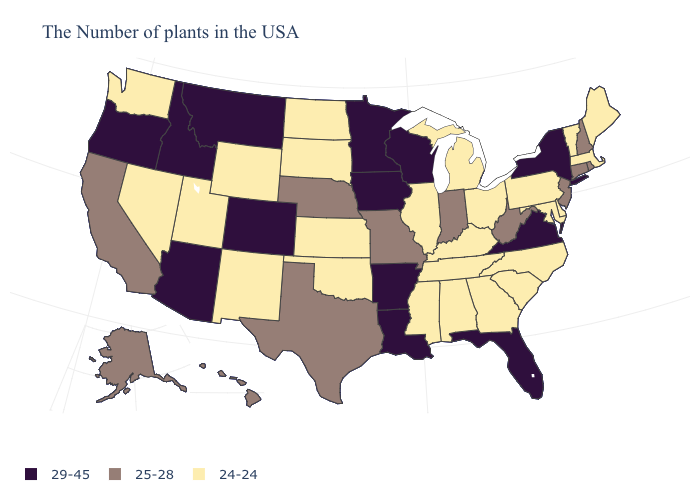What is the highest value in states that border Kansas?
Short answer required. 29-45. Is the legend a continuous bar?
Quick response, please. No. Name the states that have a value in the range 25-28?
Be succinct. Rhode Island, New Hampshire, Connecticut, New Jersey, West Virginia, Indiana, Missouri, Nebraska, Texas, California, Alaska, Hawaii. Which states have the lowest value in the West?
Quick response, please. Wyoming, New Mexico, Utah, Nevada, Washington. What is the lowest value in the USA?
Concise answer only. 24-24. What is the lowest value in the USA?
Concise answer only. 24-24. Name the states that have a value in the range 24-24?
Answer briefly. Maine, Massachusetts, Vermont, Delaware, Maryland, Pennsylvania, North Carolina, South Carolina, Ohio, Georgia, Michigan, Kentucky, Alabama, Tennessee, Illinois, Mississippi, Kansas, Oklahoma, South Dakota, North Dakota, Wyoming, New Mexico, Utah, Nevada, Washington. What is the value of Florida?
Answer briefly. 29-45. What is the value of Hawaii?
Keep it brief. 25-28. Name the states that have a value in the range 29-45?
Quick response, please. New York, Virginia, Florida, Wisconsin, Louisiana, Arkansas, Minnesota, Iowa, Colorado, Montana, Arizona, Idaho, Oregon. Name the states that have a value in the range 29-45?
Short answer required. New York, Virginia, Florida, Wisconsin, Louisiana, Arkansas, Minnesota, Iowa, Colorado, Montana, Arizona, Idaho, Oregon. Which states have the lowest value in the West?
Answer briefly. Wyoming, New Mexico, Utah, Nevada, Washington. What is the value of Kansas?
Answer briefly. 24-24. Name the states that have a value in the range 24-24?
Quick response, please. Maine, Massachusetts, Vermont, Delaware, Maryland, Pennsylvania, North Carolina, South Carolina, Ohio, Georgia, Michigan, Kentucky, Alabama, Tennessee, Illinois, Mississippi, Kansas, Oklahoma, South Dakota, North Dakota, Wyoming, New Mexico, Utah, Nevada, Washington. Does Virginia have the highest value in the South?
Write a very short answer. Yes. 